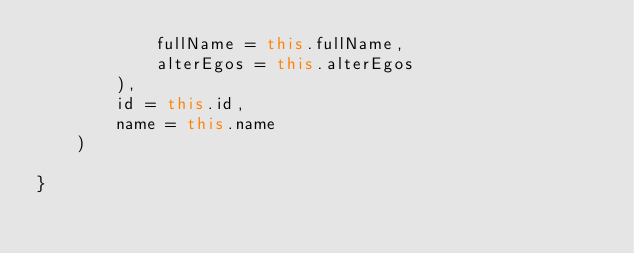<code> <loc_0><loc_0><loc_500><loc_500><_Kotlin_>            fullName = this.fullName,
            alterEgos = this.alterEgos
        ),
        id = this.id,
        name = this.name
    )

}</code> 